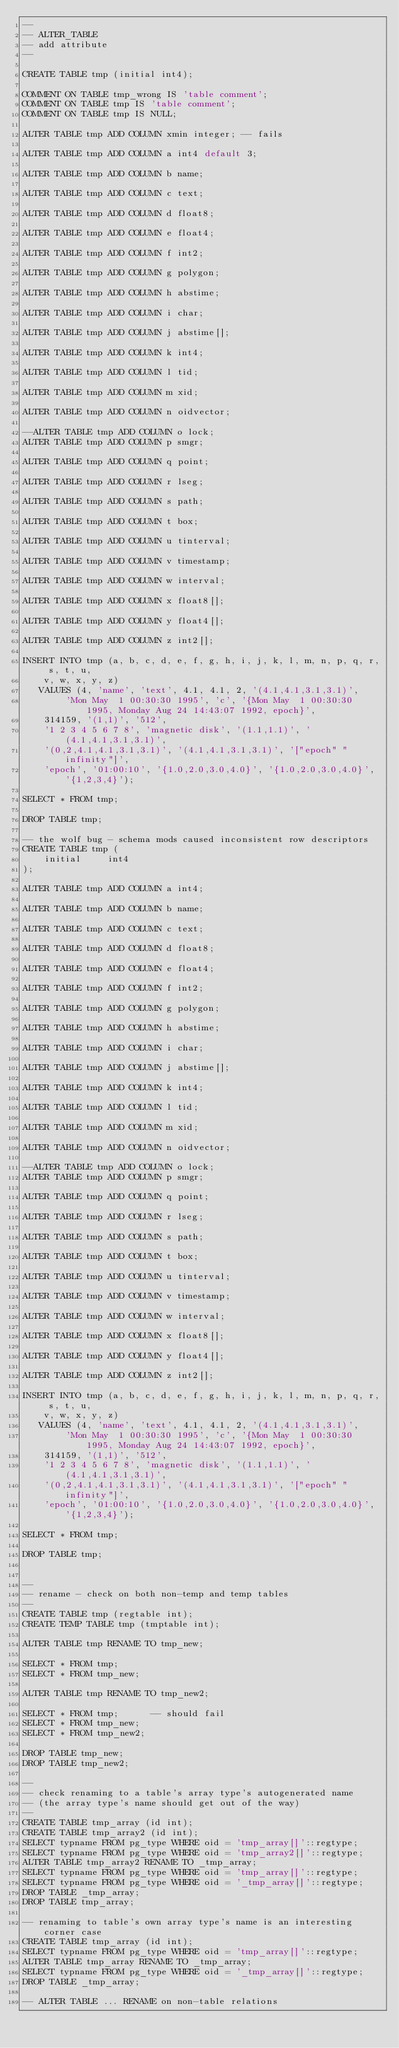Convert code to text. <code><loc_0><loc_0><loc_500><loc_500><_SQL_>--
-- ALTER_TABLE
-- add attribute
--

CREATE TABLE tmp (initial int4);

COMMENT ON TABLE tmp_wrong IS 'table comment';
COMMENT ON TABLE tmp IS 'table comment';
COMMENT ON TABLE tmp IS NULL;

ALTER TABLE tmp ADD COLUMN xmin integer; -- fails

ALTER TABLE tmp ADD COLUMN a int4 default 3;

ALTER TABLE tmp ADD COLUMN b name;

ALTER TABLE tmp ADD COLUMN c text;

ALTER TABLE tmp ADD COLUMN d float8;

ALTER TABLE tmp ADD COLUMN e float4;

ALTER TABLE tmp ADD COLUMN f int2;

ALTER TABLE tmp ADD COLUMN g polygon;

ALTER TABLE tmp ADD COLUMN h abstime;

ALTER TABLE tmp ADD COLUMN i char;

ALTER TABLE tmp ADD COLUMN j abstime[];

ALTER TABLE tmp ADD COLUMN k int4;

ALTER TABLE tmp ADD COLUMN l tid;

ALTER TABLE tmp ADD COLUMN m xid;

ALTER TABLE tmp ADD COLUMN n oidvector;

--ALTER TABLE tmp ADD COLUMN o lock;
ALTER TABLE tmp ADD COLUMN p smgr;

ALTER TABLE tmp ADD COLUMN q point;

ALTER TABLE tmp ADD COLUMN r lseg;

ALTER TABLE tmp ADD COLUMN s path;

ALTER TABLE tmp ADD COLUMN t box;

ALTER TABLE tmp ADD COLUMN u tinterval;

ALTER TABLE tmp ADD COLUMN v timestamp;

ALTER TABLE tmp ADD COLUMN w interval;

ALTER TABLE tmp ADD COLUMN x float8[];

ALTER TABLE tmp ADD COLUMN y float4[];

ALTER TABLE tmp ADD COLUMN z int2[];

INSERT INTO tmp (a, b, c, d, e, f, g, h, i, j, k, l, m, n, p, q, r, s, t, u,
	v, w, x, y, z)
   VALUES (4, 'name', 'text', 4.1, 4.1, 2, '(4.1,4.1,3.1,3.1)',
        'Mon May  1 00:30:30 1995', 'c', '{Mon May  1 00:30:30 1995, Monday Aug 24 14:43:07 1992, epoch}',
	314159, '(1,1)', '512',
	'1 2 3 4 5 6 7 8', 'magnetic disk', '(1.1,1.1)', '(4.1,4.1,3.1,3.1)',
	'(0,2,4.1,4.1,3.1,3.1)', '(4.1,4.1,3.1,3.1)', '["epoch" "infinity"]',
	'epoch', '01:00:10', '{1.0,2.0,3.0,4.0}', '{1.0,2.0,3.0,4.0}', '{1,2,3,4}');

SELECT * FROM tmp;

DROP TABLE tmp;

-- the wolf bug - schema mods caused inconsistent row descriptors
CREATE TABLE tmp (
	initial 	int4
);

ALTER TABLE tmp ADD COLUMN a int4;

ALTER TABLE tmp ADD COLUMN b name;

ALTER TABLE tmp ADD COLUMN c text;

ALTER TABLE tmp ADD COLUMN d float8;

ALTER TABLE tmp ADD COLUMN e float4;

ALTER TABLE tmp ADD COLUMN f int2;

ALTER TABLE tmp ADD COLUMN g polygon;

ALTER TABLE tmp ADD COLUMN h abstime;

ALTER TABLE tmp ADD COLUMN i char;

ALTER TABLE tmp ADD COLUMN j abstime[];

ALTER TABLE tmp ADD COLUMN k int4;

ALTER TABLE tmp ADD COLUMN l tid;

ALTER TABLE tmp ADD COLUMN m xid;

ALTER TABLE tmp ADD COLUMN n oidvector;

--ALTER TABLE tmp ADD COLUMN o lock;
ALTER TABLE tmp ADD COLUMN p smgr;

ALTER TABLE tmp ADD COLUMN q point;

ALTER TABLE tmp ADD COLUMN r lseg;

ALTER TABLE tmp ADD COLUMN s path;

ALTER TABLE tmp ADD COLUMN t box;

ALTER TABLE tmp ADD COLUMN u tinterval;

ALTER TABLE tmp ADD COLUMN v timestamp;

ALTER TABLE tmp ADD COLUMN w interval;

ALTER TABLE tmp ADD COLUMN x float8[];

ALTER TABLE tmp ADD COLUMN y float4[];

ALTER TABLE tmp ADD COLUMN z int2[];

INSERT INTO tmp (a, b, c, d, e, f, g, h, i, j, k, l, m, n, p, q, r, s, t, u,
	v, w, x, y, z)
   VALUES (4, 'name', 'text', 4.1, 4.1, 2, '(4.1,4.1,3.1,3.1)',
        'Mon May  1 00:30:30 1995', 'c', '{Mon May  1 00:30:30 1995, Monday Aug 24 14:43:07 1992, epoch}',
	314159, '(1,1)', '512',
	'1 2 3 4 5 6 7 8', 'magnetic disk', '(1.1,1.1)', '(4.1,4.1,3.1,3.1)',
	'(0,2,4.1,4.1,3.1,3.1)', '(4.1,4.1,3.1,3.1)', '["epoch" "infinity"]',
	'epoch', '01:00:10', '{1.0,2.0,3.0,4.0}', '{1.0,2.0,3.0,4.0}', '{1,2,3,4}');

SELECT * FROM tmp;

DROP TABLE tmp;


--
-- rename - check on both non-temp and temp tables
--
CREATE TABLE tmp (regtable int);
CREATE TEMP TABLE tmp (tmptable int);

ALTER TABLE tmp RENAME TO tmp_new;

SELECT * FROM tmp;
SELECT * FROM tmp_new;

ALTER TABLE tmp RENAME TO tmp_new2;

SELECT * FROM tmp;		-- should fail
SELECT * FROM tmp_new;
SELECT * FROM tmp_new2;

DROP TABLE tmp_new;
DROP TABLE tmp_new2;

--
-- check renaming to a table's array type's autogenerated name
-- (the array type's name should get out of the way)
--
CREATE TABLE tmp_array (id int);
CREATE TABLE tmp_array2 (id int);
SELECT typname FROM pg_type WHERE oid = 'tmp_array[]'::regtype;
SELECT typname FROM pg_type WHERE oid = 'tmp_array2[]'::regtype;
ALTER TABLE tmp_array2 RENAME TO _tmp_array;
SELECT typname FROM pg_type WHERE oid = 'tmp_array[]'::regtype;
SELECT typname FROM pg_type WHERE oid = '_tmp_array[]'::regtype;
DROP TABLE _tmp_array;
DROP TABLE tmp_array;

-- renaming to table's own array type's name is an interesting corner case
CREATE TABLE tmp_array (id int);
SELECT typname FROM pg_type WHERE oid = 'tmp_array[]'::regtype;
ALTER TABLE tmp_array RENAME TO _tmp_array;
SELECT typname FROM pg_type WHERE oid = '_tmp_array[]'::regtype;
DROP TABLE _tmp_array;

-- ALTER TABLE ... RENAME on non-table relations</code> 